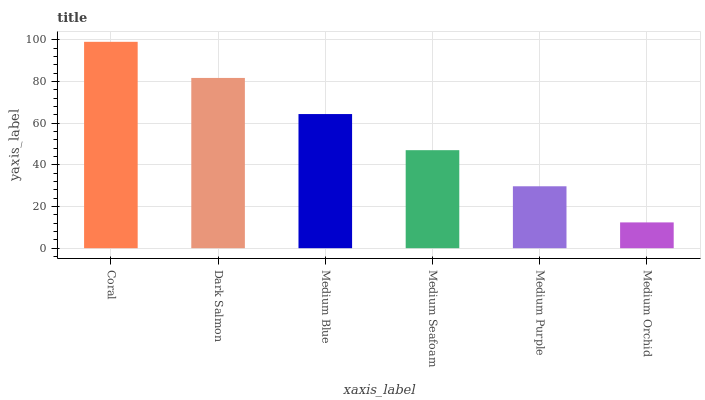Is Medium Orchid the minimum?
Answer yes or no. Yes. Is Coral the maximum?
Answer yes or no. Yes. Is Dark Salmon the minimum?
Answer yes or no. No. Is Dark Salmon the maximum?
Answer yes or no. No. Is Coral greater than Dark Salmon?
Answer yes or no. Yes. Is Dark Salmon less than Coral?
Answer yes or no. Yes. Is Dark Salmon greater than Coral?
Answer yes or no. No. Is Coral less than Dark Salmon?
Answer yes or no. No. Is Medium Blue the high median?
Answer yes or no. Yes. Is Medium Seafoam the low median?
Answer yes or no. Yes. Is Medium Seafoam the high median?
Answer yes or no. No. Is Dark Salmon the low median?
Answer yes or no. No. 